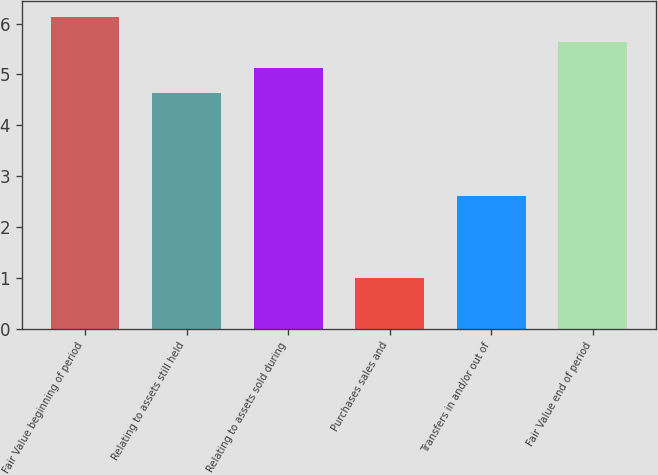Convert chart to OTSL. <chart><loc_0><loc_0><loc_500><loc_500><bar_chart><fcel>Fair Value beginning of period<fcel>Relating to assets still held<fcel>Relating to assets sold during<fcel>Purchases sales and<fcel>Transfers in and/or out of<fcel>Fair Value end of period<nl><fcel>6.13<fcel>4.63<fcel>5.13<fcel>1<fcel>2.6<fcel>5.63<nl></chart> 